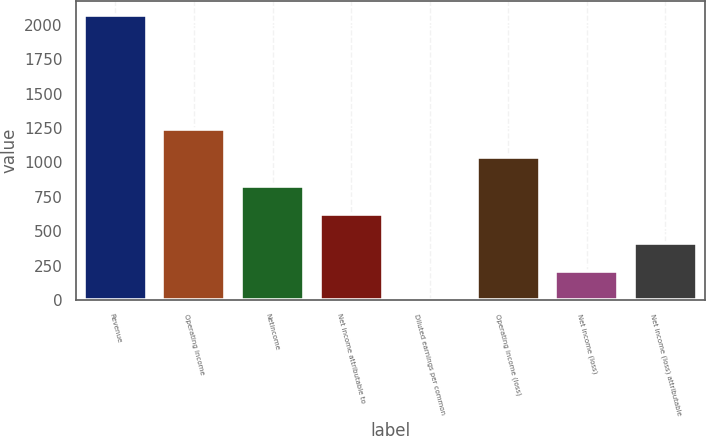Convert chart. <chart><loc_0><loc_0><loc_500><loc_500><bar_chart><fcel>Revenue<fcel>Operating income<fcel>Netincome<fcel>Net income attributable to<fcel>Diluted earnings per common<fcel>Operating income (loss)<fcel>Net income (loss)<fcel>Net income (loss) attributable<nl><fcel>2073.5<fcel>1244.24<fcel>829.6<fcel>622.28<fcel>0.32<fcel>1036.92<fcel>207.64<fcel>414.96<nl></chart> 